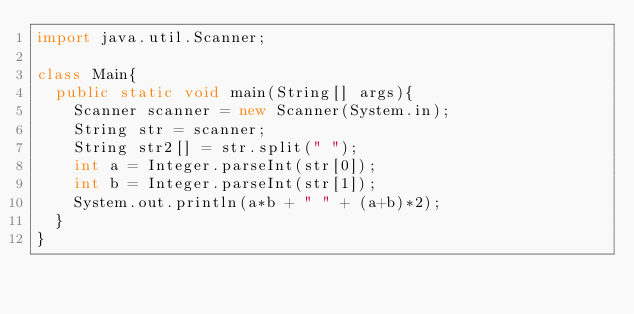<code> <loc_0><loc_0><loc_500><loc_500><_Java_>import java.util.Scanner;

class Main{
  public static void main(String[] args){
    Scanner scanner = new Scanner(System.in);
    String str = scanner;
    String str2[] = str.split(" ");
    int a = Integer.parseInt(str[0]);
    int b = Integer.parseInt(str[1]);
    System.out.println(a*b + " " + (a+b)*2);
  }
}
</code> 